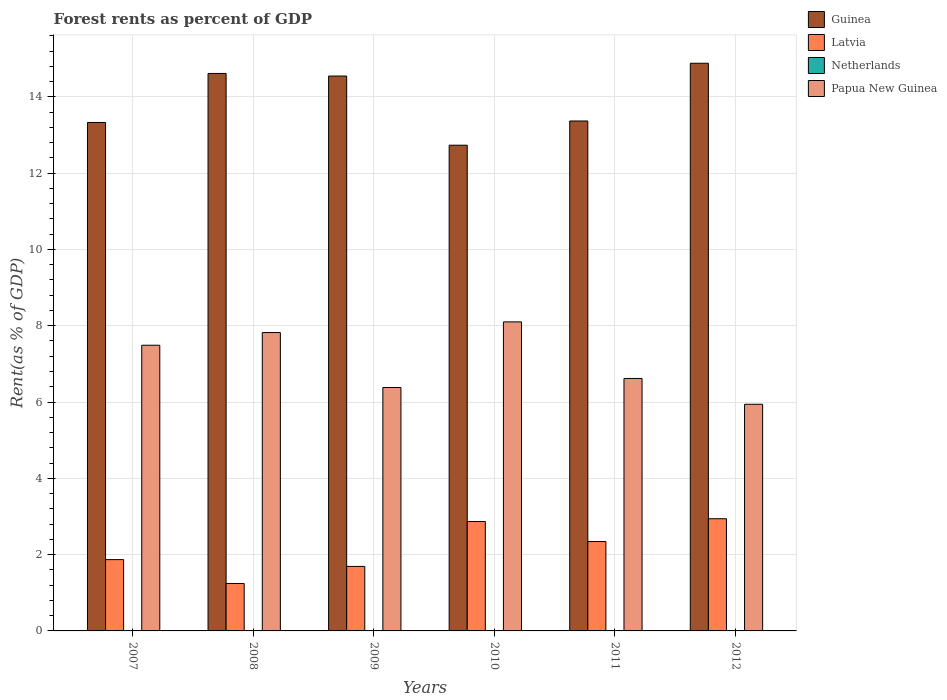How many different coloured bars are there?
Your answer should be very brief. 4. Are the number of bars per tick equal to the number of legend labels?
Ensure brevity in your answer.  Yes. Are the number of bars on each tick of the X-axis equal?
Your answer should be very brief. Yes. How many bars are there on the 4th tick from the right?
Your answer should be very brief. 4. What is the forest rent in Papua New Guinea in 2010?
Provide a short and direct response. 8.1. Across all years, what is the maximum forest rent in Papua New Guinea?
Your answer should be compact. 8.1. Across all years, what is the minimum forest rent in Netherlands?
Your response must be concise. 0.01. In which year was the forest rent in Netherlands minimum?
Give a very brief answer. 2012. What is the total forest rent in Papua New Guinea in the graph?
Keep it short and to the point. 42.35. What is the difference between the forest rent in Guinea in 2008 and that in 2009?
Provide a succinct answer. 0.07. What is the difference between the forest rent in Papua New Guinea in 2007 and the forest rent in Netherlands in 2012?
Your answer should be compact. 7.48. What is the average forest rent in Latvia per year?
Provide a short and direct response. 2.16. In the year 2007, what is the difference between the forest rent in Latvia and forest rent in Guinea?
Provide a short and direct response. -11.46. In how many years, is the forest rent in Papua New Guinea greater than 9.6 %?
Keep it short and to the point. 0. What is the ratio of the forest rent in Guinea in 2009 to that in 2012?
Your answer should be very brief. 0.98. Is the difference between the forest rent in Latvia in 2009 and 2011 greater than the difference between the forest rent in Guinea in 2009 and 2011?
Ensure brevity in your answer.  No. What is the difference between the highest and the second highest forest rent in Latvia?
Provide a succinct answer. 0.07. What is the difference between the highest and the lowest forest rent in Papua New Guinea?
Your response must be concise. 2.16. In how many years, is the forest rent in Guinea greater than the average forest rent in Guinea taken over all years?
Provide a succinct answer. 3. What does the 2nd bar from the left in 2010 represents?
Offer a terse response. Latvia. How many bars are there?
Give a very brief answer. 24. Are the values on the major ticks of Y-axis written in scientific E-notation?
Provide a succinct answer. No. Does the graph contain grids?
Keep it short and to the point. Yes. How many legend labels are there?
Give a very brief answer. 4. How are the legend labels stacked?
Your answer should be very brief. Vertical. What is the title of the graph?
Offer a very short reply. Forest rents as percent of GDP. Does "Bhutan" appear as one of the legend labels in the graph?
Provide a succinct answer. No. What is the label or title of the Y-axis?
Offer a terse response. Rent(as % of GDP). What is the Rent(as % of GDP) of Guinea in 2007?
Your answer should be compact. 13.33. What is the Rent(as % of GDP) in Latvia in 2007?
Offer a very short reply. 1.87. What is the Rent(as % of GDP) in Netherlands in 2007?
Your response must be concise. 0.01. What is the Rent(as % of GDP) in Papua New Guinea in 2007?
Keep it short and to the point. 7.49. What is the Rent(as % of GDP) of Guinea in 2008?
Provide a succinct answer. 14.61. What is the Rent(as % of GDP) in Latvia in 2008?
Your answer should be very brief. 1.24. What is the Rent(as % of GDP) of Netherlands in 2008?
Keep it short and to the point. 0.01. What is the Rent(as % of GDP) of Papua New Guinea in 2008?
Your answer should be compact. 7.82. What is the Rent(as % of GDP) of Guinea in 2009?
Make the answer very short. 14.54. What is the Rent(as % of GDP) of Latvia in 2009?
Give a very brief answer. 1.69. What is the Rent(as % of GDP) of Netherlands in 2009?
Give a very brief answer. 0.01. What is the Rent(as % of GDP) of Papua New Guinea in 2009?
Give a very brief answer. 6.38. What is the Rent(as % of GDP) of Guinea in 2010?
Keep it short and to the point. 12.73. What is the Rent(as % of GDP) of Latvia in 2010?
Keep it short and to the point. 2.87. What is the Rent(as % of GDP) of Netherlands in 2010?
Your answer should be compact. 0.01. What is the Rent(as % of GDP) in Papua New Guinea in 2010?
Offer a very short reply. 8.1. What is the Rent(as % of GDP) in Guinea in 2011?
Provide a succinct answer. 13.37. What is the Rent(as % of GDP) in Latvia in 2011?
Ensure brevity in your answer.  2.34. What is the Rent(as % of GDP) in Netherlands in 2011?
Offer a terse response. 0.01. What is the Rent(as % of GDP) of Papua New Guinea in 2011?
Make the answer very short. 6.62. What is the Rent(as % of GDP) in Guinea in 2012?
Make the answer very short. 14.88. What is the Rent(as % of GDP) in Latvia in 2012?
Give a very brief answer. 2.94. What is the Rent(as % of GDP) in Netherlands in 2012?
Your response must be concise. 0.01. What is the Rent(as % of GDP) in Papua New Guinea in 2012?
Keep it short and to the point. 5.94. Across all years, what is the maximum Rent(as % of GDP) in Guinea?
Offer a terse response. 14.88. Across all years, what is the maximum Rent(as % of GDP) in Latvia?
Ensure brevity in your answer.  2.94. Across all years, what is the maximum Rent(as % of GDP) of Netherlands?
Offer a terse response. 0.01. Across all years, what is the maximum Rent(as % of GDP) of Papua New Guinea?
Offer a very short reply. 8.1. Across all years, what is the minimum Rent(as % of GDP) of Guinea?
Give a very brief answer. 12.73. Across all years, what is the minimum Rent(as % of GDP) of Latvia?
Make the answer very short. 1.24. Across all years, what is the minimum Rent(as % of GDP) of Netherlands?
Ensure brevity in your answer.  0.01. Across all years, what is the minimum Rent(as % of GDP) of Papua New Guinea?
Provide a succinct answer. 5.94. What is the total Rent(as % of GDP) in Guinea in the graph?
Offer a very short reply. 83.46. What is the total Rent(as % of GDP) of Latvia in the graph?
Ensure brevity in your answer.  12.96. What is the total Rent(as % of GDP) of Netherlands in the graph?
Offer a terse response. 0.04. What is the total Rent(as % of GDP) in Papua New Guinea in the graph?
Your answer should be compact. 42.35. What is the difference between the Rent(as % of GDP) in Guinea in 2007 and that in 2008?
Give a very brief answer. -1.28. What is the difference between the Rent(as % of GDP) of Latvia in 2007 and that in 2008?
Give a very brief answer. 0.63. What is the difference between the Rent(as % of GDP) in Netherlands in 2007 and that in 2008?
Keep it short and to the point. -0. What is the difference between the Rent(as % of GDP) in Papua New Guinea in 2007 and that in 2008?
Make the answer very short. -0.33. What is the difference between the Rent(as % of GDP) in Guinea in 2007 and that in 2009?
Keep it short and to the point. -1.22. What is the difference between the Rent(as % of GDP) of Latvia in 2007 and that in 2009?
Keep it short and to the point. 0.18. What is the difference between the Rent(as % of GDP) in Papua New Guinea in 2007 and that in 2009?
Keep it short and to the point. 1.11. What is the difference between the Rent(as % of GDP) of Guinea in 2007 and that in 2010?
Offer a very short reply. 0.6. What is the difference between the Rent(as % of GDP) of Latvia in 2007 and that in 2010?
Offer a terse response. -1. What is the difference between the Rent(as % of GDP) of Netherlands in 2007 and that in 2010?
Your answer should be very brief. -0. What is the difference between the Rent(as % of GDP) of Papua New Guinea in 2007 and that in 2010?
Provide a short and direct response. -0.61. What is the difference between the Rent(as % of GDP) in Guinea in 2007 and that in 2011?
Provide a succinct answer. -0.04. What is the difference between the Rent(as % of GDP) of Latvia in 2007 and that in 2011?
Your response must be concise. -0.47. What is the difference between the Rent(as % of GDP) of Netherlands in 2007 and that in 2011?
Your answer should be very brief. 0. What is the difference between the Rent(as % of GDP) in Papua New Guinea in 2007 and that in 2011?
Keep it short and to the point. 0.87. What is the difference between the Rent(as % of GDP) of Guinea in 2007 and that in 2012?
Offer a very short reply. -1.55. What is the difference between the Rent(as % of GDP) of Latvia in 2007 and that in 2012?
Ensure brevity in your answer.  -1.07. What is the difference between the Rent(as % of GDP) in Netherlands in 2007 and that in 2012?
Provide a succinct answer. 0. What is the difference between the Rent(as % of GDP) of Papua New Guinea in 2007 and that in 2012?
Keep it short and to the point. 1.55. What is the difference between the Rent(as % of GDP) in Guinea in 2008 and that in 2009?
Keep it short and to the point. 0.07. What is the difference between the Rent(as % of GDP) of Latvia in 2008 and that in 2009?
Ensure brevity in your answer.  -0.45. What is the difference between the Rent(as % of GDP) in Netherlands in 2008 and that in 2009?
Your answer should be very brief. 0. What is the difference between the Rent(as % of GDP) of Papua New Guinea in 2008 and that in 2009?
Keep it short and to the point. 1.44. What is the difference between the Rent(as % of GDP) in Guinea in 2008 and that in 2010?
Your answer should be compact. 1.88. What is the difference between the Rent(as % of GDP) in Latvia in 2008 and that in 2010?
Your answer should be compact. -1.62. What is the difference between the Rent(as % of GDP) of Netherlands in 2008 and that in 2010?
Give a very brief answer. 0. What is the difference between the Rent(as % of GDP) of Papua New Guinea in 2008 and that in 2010?
Your answer should be compact. -0.28. What is the difference between the Rent(as % of GDP) of Guinea in 2008 and that in 2011?
Ensure brevity in your answer.  1.25. What is the difference between the Rent(as % of GDP) in Latvia in 2008 and that in 2011?
Ensure brevity in your answer.  -1.1. What is the difference between the Rent(as % of GDP) of Netherlands in 2008 and that in 2011?
Your response must be concise. 0. What is the difference between the Rent(as % of GDP) of Papua New Guinea in 2008 and that in 2011?
Your answer should be compact. 1.2. What is the difference between the Rent(as % of GDP) of Guinea in 2008 and that in 2012?
Make the answer very short. -0.27. What is the difference between the Rent(as % of GDP) in Latvia in 2008 and that in 2012?
Your answer should be compact. -1.7. What is the difference between the Rent(as % of GDP) of Netherlands in 2008 and that in 2012?
Ensure brevity in your answer.  0. What is the difference between the Rent(as % of GDP) of Papua New Guinea in 2008 and that in 2012?
Offer a terse response. 1.88. What is the difference between the Rent(as % of GDP) of Guinea in 2009 and that in 2010?
Your response must be concise. 1.81. What is the difference between the Rent(as % of GDP) in Latvia in 2009 and that in 2010?
Offer a terse response. -1.18. What is the difference between the Rent(as % of GDP) in Netherlands in 2009 and that in 2010?
Provide a short and direct response. -0. What is the difference between the Rent(as % of GDP) in Papua New Guinea in 2009 and that in 2010?
Provide a short and direct response. -1.72. What is the difference between the Rent(as % of GDP) in Guinea in 2009 and that in 2011?
Give a very brief answer. 1.18. What is the difference between the Rent(as % of GDP) of Latvia in 2009 and that in 2011?
Provide a short and direct response. -0.65. What is the difference between the Rent(as % of GDP) in Netherlands in 2009 and that in 2011?
Offer a terse response. 0. What is the difference between the Rent(as % of GDP) of Papua New Guinea in 2009 and that in 2011?
Offer a very short reply. -0.24. What is the difference between the Rent(as % of GDP) in Guinea in 2009 and that in 2012?
Offer a very short reply. -0.33. What is the difference between the Rent(as % of GDP) in Latvia in 2009 and that in 2012?
Give a very brief answer. -1.25. What is the difference between the Rent(as % of GDP) of Papua New Guinea in 2009 and that in 2012?
Provide a succinct answer. 0.44. What is the difference between the Rent(as % of GDP) of Guinea in 2010 and that in 2011?
Provide a short and direct response. -0.63. What is the difference between the Rent(as % of GDP) in Latvia in 2010 and that in 2011?
Provide a short and direct response. 0.52. What is the difference between the Rent(as % of GDP) of Netherlands in 2010 and that in 2011?
Give a very brief answer. 0. What is the difference between the Rent(as % of GDP) of Papua New Guinea in 2010 and that in 2011?
Offer a very short reply. 1.48. What is the difference between the Rent(as % of GDP) of Guinea in 2010 and that in 2012?
Your response must be concise. -2.15. What is the difference between the Rent(as % of GDP) of Latvia in 2010 and that in 2012?
Make the answer very short. -0.07. What is the difference between the Rent(as % of GDP) in Netherlands in 2010 and that in 2012?
Give a very brief answer. 0. What is the difference between the Rent(as % of GDP) of Papua New Guinea in 2010 and that in 2012?
Provide a succinct answer. 2.16. What is the difference between the Rent(as % of GDP) in Guinea in 2011 and that in 2012?
Keep it short and to the point. -1.51. What is the difference between the Rent(as % of GDP) of Latvia in 2011 and that in 2012?
Keep it short and to the point. -0.6. What is the difference between the Rent(as % of GDP) in Netherlands in 2011 and that in 2012?
Your answer should be very brief. 0. What is the difference between the Rent(as % of GDP) of Papua New Guinea in 2011 and that in 2012?
Ensure brevity in your answer.  0.68. What is the difference between the Rent(as % of GDP) of Guinea in 2007 and the Rent(as % of GDP) of Latvia in 2008?
Offer a very short reply. 12.08. What is the difference between the Rent(as % of GDP) in Guinea in 2007 and the Rent(as % of GDP) in Netherlands in 2008?
Make the answer very short. 13.32. What is the difference between the Rent(as % of GDP) in Guinea in 2007 and the Rent(as % of GDP) in Papua New Guinea in 2008?
Offer a very short reply. 5.51. What is the difference between the Rent(as % of GDP) in Latvia in 2007 and the Rent(as % of GDP) in Netherlands in 2008?
Offer a terse response. 1.86. What is the difference between the Rent(as % of GDP) in Latvia in 2007 and the Rent(as % of GDP) in Papua New Guinea in 2008?
Your response must be concise. -5.95. What is the difference between the Rent(as % of GDP) in Netherlands in 2007 and the Rent(as % of GDP) in Papua New Guinea in 2008?
Ensure brevity in your answer.  -7.81. What is the difference between the Rent(as % of GDP) in Guinea in 2007 and the Rent(as % of GDP) in Latvia in 2009?
Offer a very short reply. 11.64. What is the difference between the Rent(as % of GDP) of Guinea in 2007 and the Rent(as % of GDP) of Netherlands in 2009?
Make the answer very short. 13.32. What is the difference between the Rent(as % of GDP) in Guinea in 2007 and the Rent(as % of GDP) in Papua New Guinea in 2009?
Give a very brief answer. 6.95. What is the difference between the Rent(as % of GDP) in Latvia in 2007 and the Rent(as % of GDP) in Netherlands in 2009?
Your answer should be very brief. 1.86. What is the difference between the Rent(as % of GDP) of Latvia in 2007 and the Rent(as % of GDP) of Papua New Guinea in 2009?
Keep it short and to the point. -4.51. What is the difference between the Rent(as % of GDP) of Netherlands in 2007 and the Rent(as % of GDP) of Papua New Guinea in 2009?
Offer a very short reply. -6.37. What is the difference between the Rent(as % of GDP) of Guinea in 2007 and the Rent(as % of GDP) of Latvia in 2010?
Ensure brevity in your answer.  10.46. What is the difference between the Rent(as % of GDP) in Guinea in 2007 and the Rent(as % of GDP) in Netherlands in 2010?
Your response must be concise. 13.32. What is the difference between the Rent(as % of GDP) of Guinea in 2007 and the Rent(as % of GDP) of Papua New Guinea in 2010?
Ensure brevity in your answer.  5.23. What is the difference between the Rent(as % of GDP) in Latvia in 2007 and the Rent(as % of GDP) in Netherlands in 2010?
Your answer should be very brief. 1.86. What is the difference between the Rent(as % of GDP) of Latvia in 2007 and the Rent(as % of GDP) of Papua New Guinea in 2010?
Give a very brief answer. -6.23. What is the difference between the Rent(as % of GDP) of Netherlands in 2007 and the Rent(as % of GDP) of Papua New Guinea in 2010?
Provide a succinct answer. -8.09. What is the difference between the Rent(as % of GDP) in Guinea in 2007 and the Rent(as % of GDP) in Latvia in 2011?
Ensure brevity in your answer.  10.98. What is the difference between the Rent(as % of GDP) in Guinea in 2007 and the Rent(as % of GDP) in Netherlands in 2011?
Your answer should be compact. 13.32. What is the difference between the Rent(as % of GDP) of Guinea in 2007 and the Rent(as % of GDP) of Papua New Guinea in 2011?
Your response must be concise. 6.71. What is the difference between the Rent(as % of GDP) of Latvia in 2007 and the Rent(as % of GDP) of Netherlands in 2011?
Provide a succinct answer. 1.86. What is the difference between the Rent(as % of GDP) in Latvia in 2007 and the Rent(as % of GDP) in Papua New Guinea in 2011?
Offer a terse response. -4.75. What is the difference between the Rent(as % of GDP) of Netherlands in 2007 and the Rent(as % of GDP) of Papua New Guinea in 2011?
Offer a very short reply. -6.61. What is the difference between the Rent(as % of GDP) in Guinea in 2007 and the Rent(as % of GDP) in Latvia in 2012?
Your answer should be very brief. 10.39. What is the difference between the Rent(as % of GDP) of Guinea in 2007 and the Rent(as % of GDP) of Netherlands in 2012?
Make the answer very short. 13.32. What is the difference between the Rent(as % of GDP) of Guinea in 2007 and the Rent(as % of GDP) of Papua New Guinea in 2012?
Your response must be concise. 7.39. What is the difference between the Rent(as % of GDP) in Latvia in 2007 and the Rent(as % of GDP) in Netherlands in 2012?
Keep it short and to the point. 1.86. What is the difference between the Rent(as % of GDP) of Latvia in 2007 and the Rent(as % of GDP) of Papua New Guinea in 2012?
Offer a terse response. -4.07. What is the difference between the Rent(as % of GDP) of Netherlands in 2007 and the Rent(as % of GDP) of Papua New Guinea in 2012?
Your response must be concise. -5.93. What is the difference between the Rent(as % of GDP) in Guinea in 2008 and the Rent(as % of GDP) in Latvia in 2009?
Offer a very short reply. 12.92. What is the difference between the Rent(as % of GDP) in Guinea in 2008 and the Rent(as % of GDP) in Netherlands in 2009?
Your answer should be very brief. 14.61. What is the difference between the Rent(as % of GDP) of Guinea in 2008 and the Rent(as % of GDP) of Papua New Guinea in 2009?
Provide a short and direct response. 8.23. What is the difference between the Rent(as % of GDP) of Latvia in 2008 and the Rent(as % of GDP) of Netherlands in 2009?
Provide a succinct answer. 1.24. What is the difference between the Rent(as % of GDP) of Latvia in 2008 and the Rent(as % of GDP) of Papua New Guinea in 2009?
Offer a terse response. -5.14. What is the difference between the Rent(as % of GDP) in Netherlands in 2008 and the Rent(as % of GDP) in Papua New Guinea in 2009?
Your answer should be compact. -6.37. What is the difference between the Rent(as % of GDP) of Guinea in 2008 and the Rent(as % of GDP) of Latvia in 2010?
Your response must be concise. 11.74. What is the difference between the Rent(as % of GDP) of Guinea in 2008 and the Rent(as % of GDP) of Netherlands in 2010?
Keep it short and to the point. 14.6. What is the difference between the Rent(as % of GDP) of Guinea in 2008 and the Rent(as % of GDP) of Papua New Guinea in 2010?
Offer a very short reply. 6.51. What is the difference between the Rent(as % of GDP) in Latvia in 2008 and the Rent(as % of GDP) in Netherlands in 2010?
Your answer should be compact. 1.24. What is the difference between the Rent(as % of GDP) in Latvia in 2008 and the Rent(as % of GDP) in Papua New Guinea in 2010?
Provide a succinct answer. -6.86. What is the difference between the Rent(as % of GDP) of Netherlands in 2008 and the Rent(as % of GDP) of Papua New Guinea in 2010?
Your answer should be compact. -8.09. What is the difference between the Rent(as % of GDP) in Guinea in 2008 and the Rent(as % of GDP) in Latvia in 2011?
Your answer should be very brief. 12.27. What is the difference between the Rent(as % of GDP) of Guinea in 2008 and the Rent(as % of GDP) of Netherlands in 2011?
Ensure brevity in your answer.  14.61. What is the difference between the Rent(as % of GDP) of Guinea in 2008 and the Rent(as % of GDP) of Papua New Guinea in 2011?
Make the answer very short. 8. What is the difference between the Rent(as % of GDP) of Latvia in 2008 and the Rent(as % of GDP) of Netherlands in 2011?
Ensure brevity in your answer.  1.24. What is the difference between the Rent(as % of GDP) of Latvia in 2008 and the Rent(as % of GDP) of Papua New Guinea in 2011?
Your response must be concise. -5.37. What is the difference between the Rent(as % of GDP) of Netherlands in 2008 and the Rent(as % of GDP) of Papua New Guinea in 2011?
Your response must be concise. -6.61. What is the difference between the Rent(as % of GDP) of Guinea in 2008 and the Rent(as % of GDP) of Latvia in 2012?
Ensure brevity in your answer.  11.67. What is the difference between the Rent(as % of GDP) in Guinea in 2008 and the Rent(as % of GDP) in Netherlands in 2012?
Provide a short and direct response. 14.61. What is the difference between the Rent(as % of GDP) of Guinea in 2008 and the Rent(as % of GDP) of Papua New Guinea in 2012?
Your answer should be very brief. 8.67. What is the difference between the Rent(as % of GDP) in Latvia in 2008 and the Rent(as % of GDP) in Netherlands in 2012?
Keep it short and to the point. 1.24. What is the difference between the Rent(as % of GDP) of Latvia in 2008 and the Rent(as % of GDP) of Papua New Guinea in 2012?
Offer a terse response. -4.7. What is the difference between the Rent(as % of GDP) in Netherlands in 2008 and the Rent(as % of GDP) in Papua New Guinea in 2012?
Make the answer very short. -5.93. What is the difference between the Rent(as % of GDP) in Guinea in 2009 and the Rent(as % of GDP) in Latvia in 2010?
Give a very brief answer. 11.68. What is the difference between the Rent(as % of GDP) in Guinea in 2009 and the Rent(as % of GDP) in Netherlands in 2010?
Your answer should be compact. 14.54. What is the difference between the Rent(as % of GDP) of Guinea in 2009 and the Rent(as % of GDP) of Papua New Guinea in 2010?
Ensure brevity in your answer.  6.44. What is the difference between the Rent(as % of GDP) in Latvia in 2009 and the Rent(as % of GDP) in Netherlands in 2010?
Your answer should be very brief. 1.68. What is the difference between the Rent(as % of GDP) in Latvia in 2009 and the Rent(as % of GDP) in Papua New Guinea in 2010?
Your response must be concise. -6.41. What is the difference between the Rent(as % of GDP) in Netherlands in 2009 and the Rent(as % of GDP) in Papua New Guinea in 2010?
Your answer should be compact. -8.09. What is the difference between the Rent(as % of GDP) of Guinea in 2009 and the Rent(as % of GDP) of Latvia in 2011?
Keep it short and to the point. 12.2. What is the difference between the Rent(as % of GDP) in Guinea in 2009 and the Rent(as % of GDP) in Netherlands in 2011?
Give a very brief answer. 14.54. What is the difference between the Rent(as % of GDP) in Guinea in 2009 and the Rent(as % of GDP) in Papua New Guinea in 2011?
Make the answer very short. 7.93. What is the difference between the Rent(as % of GDP) in Latvia in 2009 and the Rent(as % of GDP) in Netherlands in 2011?
Make the answer very short. 1.68. What is the difference between the Rent(as % of GDP) of Latvia in 2009 and the Rent(as % of GDP) of Papua New Guinea in 2011?
Provide a short and direct response. -4.93. What is the difference between the Rent(as % of GDP) in Netherlands in 2009 and the Rent(as % of GDP) in Papua New Guinea in 2011?
Your response must be concise. -6.61. What is the difference between the Rent(as % of GDP) in Guinea in 2009 and the Rent(as % of GDP) in Latvia in 2012?
Make the answer very short. 11.6. What is the difference between the Rent(as % of GDP) in Guinea in 2009 and the Rent(as % of GDP) in Netherlands in 2012?
Ensure brevity in your answer.  14.54. What is the difference between the Rent(as % of GDP) in Guinea in 2009 and the Rent(as % of GDP) in Papua New Guinea in 2012?
Give a very brief answer. 8.6. What is the difference between the Rent(as % of GDP) of Latvia in 2009 and the Rent(as % of GDP) of Netherlands in 2012?
Make the answer very short. 1.68. What is the difference between the Rent(as % of GDP) in Latvia in 2009 and the Rent(as % of GDP) in Papua New Guinea in 2012?
Give a very brief answer. -4.25. What is the difference between the Rent(as % of GDP) of Netherlands in 2009 and the Rent(as % of GDP) of Papua New Guinea in 2012?
Offer a terse response. -5.93. What is the difference between the Rent(as % of GDP) in Guinea in 2010 and the Rent(as % of GDP) in Latvia in 2011?
Offer a very short reply. 10.39. What is the difference between the Rent(as % of GDP) in Guinea in 2010 and the Rent(as % of GDP) in Netherlands in 2011?
Give a very brief answer. 12.72. What is the difference between the Rent(as % of GDP) in Guinea in 2010 and the Rent(as % of GDP) in Papua New Guinea in 2011?
Provide a succinct answer. 6.11. What is the difference between the Rent(as % of GDP) of Latvia in 2010 and the Rent(as % of GDP) of Netherlands in 2011?
Offer a very short reply. 2.86. What is the difference between the Rent(as % of GDP) of Latvia in 2010 and the Rent(as % of GDP) of Papua New Guinea in 2011?
Provide a short and direct response. -3.75. What is the difference between the Rent(as % of GDP) of Netherlands in 2010 and the Rent(as % of GDP) of Papua New Guinea in 2011?
Keep it short and to the point. -6.61. What is the difference between the Rent(as % of GDP) of Guinea in 2010 and the Rent(as % of GDP) of Latvia in 2012?
Your answer should be compact. 9.79. What is the difference between the Rent(as % of GDP) in Guinea in 2010 and the Rent(as % of GDP) in Netherlands in 2012?
Ensure brevity in your answer.  12.72. What is the difference between the Rent(as % of GDP) of Guinea in 2010 and the Rent(as % of GDP) of Papua New Guinea in 2012?
Offer a very short reply. 6.79. What is the difference between the Rent(as % of GDP) in Latvia in 2010 and the Rent(as % of GDP) in Netherlands in 2012?
Provide a succinct answer. 2.86. What is the difference between the Rent(as % of GDP) of Latvia in 2010 and the Rent(as % of GDP) of Papua New Guinea in 2012?
Your response must be concise. -3.07. What is the difference between the Rent(as % of GDP) of Netherlands in 2010 and the Rent(as % of GDP) of Papua New Guinea in 2012?
Offer a terse response. -5.93. What is the difference between the Rent(as % of GDP) in Guinea in 2011 and the Rent(as % of GDP) in Latvia in 2012?
Make the answer very short. 10.43. What is the difference between the Rent(as % of GDP) in Guinea in 2011 and the Rent(as % of GDP) in Netherlands in 2012?
Provide a short and direct response. 13.36. What is the difference between the Rent(as % of GDP) of Guinea in 2011 and the Rent(as % of GDP) of Papua New Guinea in 2012?
Offer a very short reply. 7.43. What is the difference between the Rent(as % of GDP) of Latvia in 2011 and the Rent(as % of GDP) of Netherlands in 2012?
Ensure brevity in your answer.  2.34. What is the difference between the Rent(as % of GDP) of Latvia in 2011 and the Rent(as % of GDP) of Papua New Guinea in 2012?
Ensure brevity in your answer.  -3.6. What is the difference between the Rent(as % of GDP) of Netherlands in 2011 and the Rent(as % of GDP) of Papua New Guinea in 2012?
Provide a succinct answer. -5.93. What is the average Rent(as % of GDP) of Guinea per year?
Give a very brief answer. 13.91. What is the average Rent(as % of GDP) in Latvia per year?
Offer a very short reply. 2.16. What is the average Rent(as % of GDP) in Netherlands per year?
Provide a short and direct response. 0.01. What is the average Rent(as % of GDP) in Papua New Guinea per year?
Your answer should be compact. 7.06. In the year 2007, what is the difference between the Rent(as % of GDP) of Guinea and Rent(as % of GDP) of Latvia?
Make the answer very short. 11.46. In the year 2007, what is the difference between the Rent(as % of GDP) in Guinea and Rent(as % of GDP) in Netherlands?
Your answer should be very brief. 13.32. In the year 2007, what is the difference between the Rent(as % of GDP) in Guinea and Rent(as % of GDP) in Papua New Guinea?
Give a very brief answer. 5.84. In the year 2007, what is the difference between the Rent(as % of GDP) of Latvia and Rent(as % of GDP) of Netherlands?
Offer a terse response. 1.86. In the year 2007, what is the difference between the Rent(as % of GDP) of Latvia and Rent(as % of GDP) of Papua New Guinea?
Offer a very short reply. -5.62. In the year 2007, what is the difference between the Rent(as % of GDP) in Netherlands and Rent(as % of GDP) in Papua New Guinea?
Offer a terse response. -7.48. In the year 2008, what is the difference between the Rent(as % of GDP) of Guinea and Rent(as % of GDP) of Latvia?
Give a very brief answer. 13.37. In the year 2008, what is the difference between the Rent(as % of GDP) of Guinea and Rent(as % of GDP) of Netherlands?
Provide a succinct answer. 14.6. In the year 2008, what is the difference between the Rent(as % of GDP) of Guinea and Rent(as % of GDP) of Papua New Guinea?
Your response must be concise. 6.79. In the year 2008, what is the difference between the Rent(as % of GDP) of Latvia and Rent(as % of GDP) of Netherlands?
Offer a terse response. 1.24. In the year 2008, what is the difference between the Rent(as % of GDP) in Latvia and Rent(as % of GDP) in Papua New Guinea?
Provide a succinct answer. -6.58. In the year 2008, what is the difference between the Rent(as % of GDP) in Netherlands and Rent(as % of GDP) in Papua New Guinea?
Offer a terse response. -7.81. In the year 2009, what is the difference between the Rent(as % of GDP) of Guinea and Rent(as % of GDP) of Latvia?
Offer a very short reply. 12.85. In the year 2009, what is the difference between the Rent(as % of GDP) in Guinea and Rent(as % of GDP) in Netherlands?
Make the answer very short. 14.54. In the year 2009, what is the difference between the Rent(as % of GDP) in Guinea and Rent(as % of GDP) in Papua New Guinea?
Your answer should be compact. 8.16. In the year 2009, what is the difference between the Rent(as % of GDP) of Latvia and Rent(as % of GDP) of Netherlands?
Offer a very short reply. 1.68. In the year 2009, what is the difference between the Rent(as % of GDP) of Latvia and Rent(as % of GDP) of Papua New Guinea?
Your response must be concise. -4.69. In the year 2009, what is the difference between the Rent(as % of GDP) of Netherlands and Rent(as % of GDP) of Papua New Guinea?
Make the answer very short. -6.37. In the year 2010, what is the difference between the Rent(as % of GDP) in Guinea and Rent(as % of GDP) in Latvia?
Your response must be concise. 9.86. In the year 2010, what is the difference between the Rent(as % of GDP) in Guinea and Rent(as % of GDP) in Netherlands?
Ensure brevity in your answer.  12.72. In the year 2010, what is the difference between the Rent(as % of GDP) in Guinea and Rent(as % of GDP) in Papua New Guinea?
Offer a very short reply. 4.63. In the year 2010, what is the difference between the Rent(as % of GDP) of Latvia and Rent(as % of GDP) of Netherlands?
Your answer should be compact. 2.86. In the year 2010, what is the difference between the Rent(as % of GDP) of Latvia and Rent(as % of GDP) of Papua New Guinea?
Keep it short and to the point. -5.23. In the year 2010, what is the difference between the Rent(as % of GDP) in Netherlands and Rent(as % of GDP) in Papua New Guinea?
Keep it short and to the point. -8.09. In the year 2011, what is the difference between the Rent(as % of GDP) in Guinea and Rent(as % of GDP) in Latvia?
Your response must be concise. 11.02. In the year 2011, what is the difference between the Rent(as % of GDP) of Guinea and Rent(as % of GDP) of Netherlands?
Ensure brevity in your answer.  13.36. In the year 2011, what is the difference between the Rent(as % of GDP) of Guinea and Rent(as % of GDP) of Papua New Guinea?
Make the answer very short. 6.75. In the year 2011, what is the difference between the Rent(as % of GDP) of Latvia and Rent(as % of GDP) of Netherlands?
Make the answer very short. 2.34. In the year 2011, what is the difference between the Rent(as % of GDP) in Latvia and Rent(as % of GDP) in Papua New Guinea?
Offer a terse response. -4.27. In the year 2011, what is the difference between the Rent(as % of GDP) of Netherlands and Rent(as % of GDP) of Papua New Guinea?
Your answer should be compact. -6.61. In the year 2012, what is the difference between the Rent(as % of GDP) of Guinea and Rent(as % of GDP) of Latvia?
Keep it short and to the point. 11.94. In the year 2012, what is the difference between the Rent(as % of GDP) in Guinea and Rent(as % of GDP) in Netherlands?
Offer a very short reply. 14.87. In the year 2012, what is the difference between the Rent(as % of GDP) in Guinea and Rent(as % of GDP) in Papua New Guinea?
Give a very brief answer. 8.94. In the year 2012, what is the difference between the Rent(as % of GDP) of Latvia and Rent(as % of GDP) of Netherlands?
Ensure brevity in your answer.  2.93. In the year 2012, what is the difference between the Rent(as % of GDP) of Latvia and Rent(as % of GDP) of Papua New Guinea?
Your response must be concise. -3. In the year 2012, what is the difference between the Rent(as % of GDP) in Netherlands and Rent(as % of GDP) in Papua New Guinea?
Your answer should be very brief. -5.93. What is the ratio of the Rent(as % of GDP) of Guinea in 2007 to that in 2008?
Provide a succinct answer. 0.91. What is the ratio of the Rent(as % of GDP) of Latvia in 2007 to that in 2008?
Your answer should be compact. 1.5. What is the ratio of the Rent(as % of GDP) in Netherlands in 2007 to that in 2008?
Your response must be concise. 0.87. What is the ratio of the Rent(as % of GDP) in Papua New Guinea in 2007 to that in 2008?
Offer a terse response. 0.96. What is the ratio of the Rent(as % of GDP) of Guinea in 2007 to that in 2009?
Provide a succinct answer. 0.92. What is the ratio of the Rent(as % of GDP) in Latvia in 2007 to that in 2009?
Provide a succinct answer. 1.11. What is the ratio of the Rent(as % of GDP) in Papua New Guinea in 2007 to that in 2009?
Your answer should be compact. 1.17. What is the ratio of the Rent(as % of GDP) of Guinea in 2007 to that in 2010?
Provide a succinct answer. 1.05. What is the ratio of the Rent(as % of GDP) of Latvia in 2007 to that in 2010?
Make the answer very short. 0.65. What is the ratio of the Rent(as % of GDP) in Netherlands in 2007 to that in 2010?
Give a very brief answer. 0.88. What is the ratio of the Rent(as % of GDP) of Papua New Guinea in 2007 to that in 2010?
Ensure brevity in your answer.  0.92. What is the ratio of the Rent(as % of GDP) of Latvia in 2007 to that in 2011?
Ensure brevity in your answer.  0.8. What is the ratio of the Rent(as % of GDP) of Netherlands in 2007 to that in 2011?
Make the answer very short. 1.05. What is the ratio of the Rent(as % of GDP) in Papua New Guinea in 2007 to that in 2011?
Offer a very short reply. 1.13. What is the ratio of the Rent(as % of GDP) of Guinea in 2007 to that in 2012?
Keep it short and to the point. 0.9. What is the ratio of the Rent(as % of GDP) of Latvia in 2007 to that in 2012?
Your response must be concise. 0.64. What is the ratio of the Rent(as % of GDP) of Netherlands in 2007 to that in 2012?
Your answer should be very brief. 1.05. What is the ratio of the Rent(as % of GDP) of Papua New Guinea in 2007 to that in 2012?
Your answer should be very brief. 1.26. What is the ratio of the Rent(as % of GDP) in Latvia in 2008 to that in 2009?
Offer a terse response. 0.74. What is the ratio of the Rent(as % of GDP) of Netherlands in 2008 to that in 2009?
Ensure brevity in your answer.  1.18. What is the ratio of the Rent(as % of GDP) of Papua New Guinea in 2008 to that in 2009?
Your answer should be compact. 1.23. What is the ratio of the Rent(as % of GDP) of Guinea in 2008 to that in 2010?
Your answer should be compact. 1.15. What is the ratio of the Rent(as % of GDP) in Latvia in 2008 to that in 2010?
Ensure brevity in your answer.  0.43. What is the ratio of the Rent(as % of GDP) in Netherlands in 2008 to that in 2010?
Offer a terse response. 1.02. What is the ratio of the Rent(as % of GDP) of Papua New Guinea in 2008 to that in 2010?
Keep it short and to the point. 0.97. What is the ratio of the Rent(as % of GDP) of Guinea in 2008 to that in 2011?
Provide a short and direct response. 1.09. What is the ratio of the Rent(as % of GDP) of Latvia in 2008 to that in 2011?
Give a very brief answer. 0.53. What is the ratio of the Rent(as % of GDP) of Netherlands in 2008 to that in 2011?
Your answer should be very brief. 1.21. What is the ratio of the Rent(as % of GDP) in Papua New Guinea in 2008 to that in 2011?
Offer a very short reply. 1.18. What is the ratio of the Rent(as % of GDP) of Guinea in 2008 to that in 2012?
Your response must be concise. 0.98. What is the ratio of the Rent(as % of GDP) of Latvia in 2008 to that in 2012?
Provide a succinct answer. 0.42. What is the ratio of the Rent(as % of GDP) in Netherlands in 2008 to that in 2012?
Your answer should be compact. 1.21. What is the ratio of the Rent(as % of GDP) in Papua New Guinea in 2008 to that in 2012?
Make the answer very short. 1.32. What is the ratio of the Rent(as % of GDP) of Guinea in 2009 to that in 2010?
Your answer should be very brief. 1.14. What is the ratio of the Rent(as % of GDP) in Latvia in 2009 to that in 2010?
Offer a very short reply. 0.59. What is the ratio of the Rent(as % of GDP) in Netherlands in 2009 to that in 2010?
Provide a short and direct response. 0.86. What is the ratio of the Rent(as % of GDP) of Papua New Guinea in 2009 to that in 2010?
Offer a very short reply. 0.79. What is the ratio of the Rent(as % of GDP) of Guinea in 2009 to that in 2011?
Provide a succinct answer. 1.09. What is the ratio of the Rent(as % of GDP) of Latvia in 2009 to that in 2011?
Make the answer very short. 0.72. What is the ratio of the Rent(as % of GDP) in Netherlands in 2009 to that in 2011?
Provide a succinct answer. 1.02. What is the ratio of the Rent(as % of GDP) of Papua New Guinea in 2009 to that in 2011?
Ensure brevity in your answer.  0.96. What is the ratio of the Rent(as % of GDP) in Guinea in 2009 to that in 2012?
Provide a succinct answer. 0.98. What is the ratio of the Rent(as % of GDP) of Latvia in 2009 to that in 2012?
Your answer should be compact. 0.58. What is the ratio of the Rent(as % of GDP) of Netherlands in 2009 to that in 2012?
Your response must be concise. 1.03. What is the ratio of the Rent(as % of GDP) of Papua New Guinea in 2009 to that in 2012?
Your answer should be very brief. 1.07. What is the ratio of the Rent(as % of GDP) of Guinea in 2010 to that in 2011?
Ensure brevity in your answer.  0.95. What is the ratio of the Rent(as % of GDP) in Latvia in 2010 to that in 2011?
Ensure brevity in your answer.  1.22. What is the ratio of the Rent(as % of GDP) of Netherlands in 2010 to that in 2011?
Your answer should be very brief. 1.19. What is the ratio of the Rent(as % of GDP) of Papua New Guinea in 2010 to that in 2011?
Provide a short and direct response. 1.22. What is the ratio of the Rent(as % of GDP) in Guinea in 2010 to that in 2012?
Keep it short and to the point. 0.86. What is the ratio of the Rent(as % of GDP) in Latvia in 2010 to that in 2012?
Ensure brevity in your answer.  0.98. What is the ratio of the Rent(as % of GDP) in Netherlands in 2010 to that in 2012?
Your answer should be compact. 1.19. What is the ratio of the Rent(as % of GDP) in Papua New Guinea in 2010 to that in 2012?
Your answer should be very brief. 1.36. What is the ratio of the Rent(as % of GDP) of Guinea in 2011 to that in 2012?
Offer a terse response. 0.9. What is the ratio of the Rent(as % of GDP) in Latvia in 2011 to that in 2012?
Offer a terse response. 0.8. What is the ratio of the Rent(as % of GDP) in Netherlands in 2011 to that in 2012?
Offer a very short reply. 1. What is the ratio of the Rent(as % of GDP) of Papua New Guinea in 2011 to that in 2012?
Provide a succinct answer. 1.11. What is the difference between the highest and the second highest Rent(as % of GDP) of Guinea?
Offer a terse response. 0.27. What is the difference between the highest and the second highest Rent(as % of GDP) of Latvia?
Ensure brevity in your answer.  0.07. What is the difference between the highest and the second highest Rent(as % of GDP) in Papua New Guinea?
Give a very brief answer. 0.28. What is the difference between the highest and the lowest Rent(as % of GDP) in Guinea?
Your answer should be compact. 2.15. What is the difference between the highest and the lowest Rent(as % of GDP) of Latvia?
Your answer should be compact. 1.7. What is the difference between the highest and the lowest Rent(as % of GDP) of Netherlands?
Your answer should be compact. 0. What is the difference between the highest and the lowest Rent(as % of GDP) in Papua New Guinea?
Offer a very short reply. 2.16. 